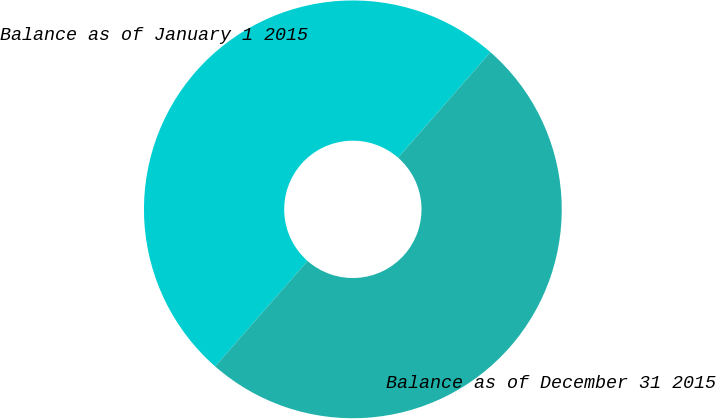Convert chart to OTSL. <chart><loc_0><loc_0><loc_500><loc_500><pie_chart><fcel>Balance as of January 1 2015<fcel>Balance as of December 31 2015<nl><fcel>49.99%<fcel>50.01%<nl></chart> 